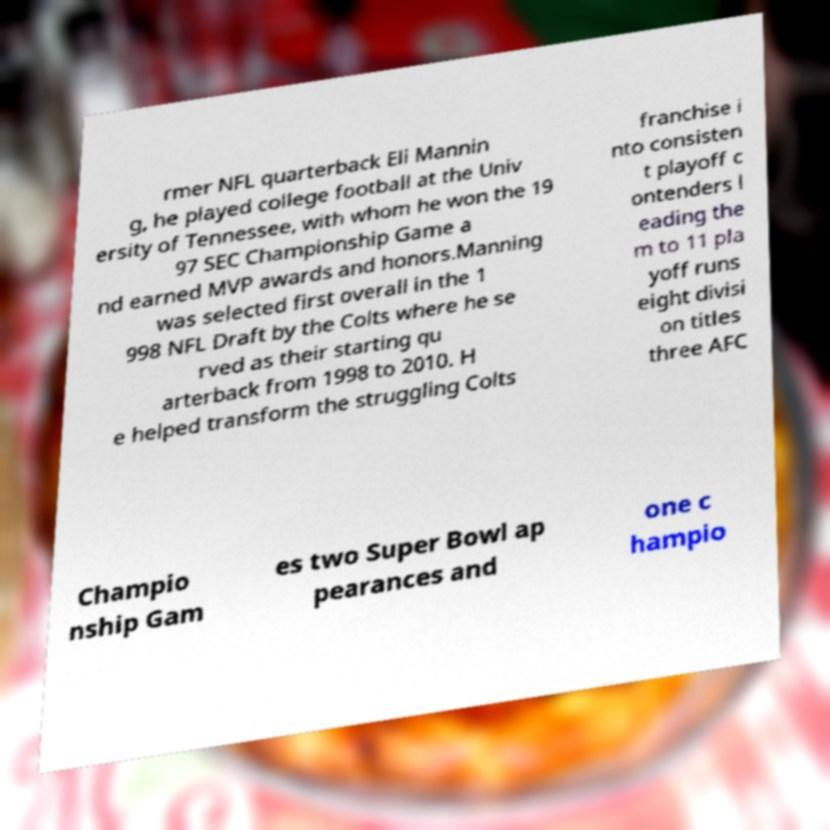Can you accurately transcribe the text from the provided image for me? rmer NFL quarterback Eli Mannin g, he played college football at the Univ ersity of Tennessee, with whom he won the 19 97 SEC Championship Game a nd earned MVP awards and honors.Manning was selected first overall in the 1 998 NFL Draft by the Colts where he se rved as their starting qu arterback from 1998 to 2010. H e helped transform the struggling Colts franchise i nto consisten t playoff c ontenders l eading the m to 11 pla yoff runs eight divisi on titles three AFC Champio nship Gam es two Super Bowl ap pearances and one c hampio 